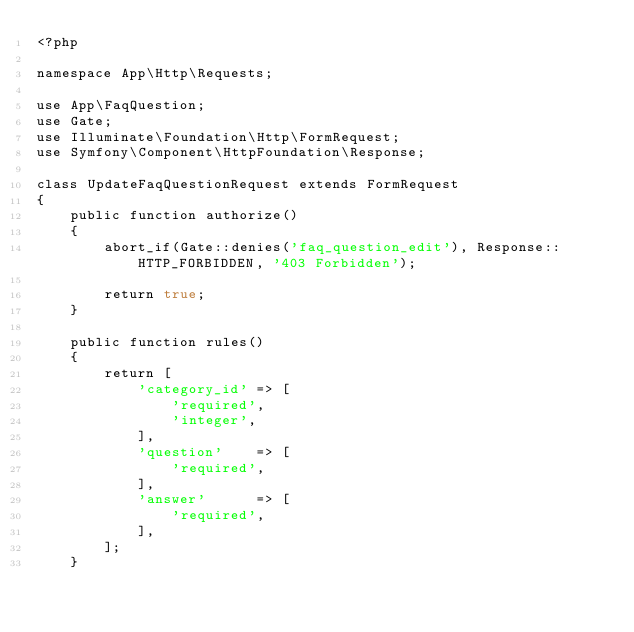Convert code to text. <code><loc_0><loc_0><loc_500><loc_500><_PHP_><?php

namespace App\Http\Requests;

use App\FaqQuestion;
use Gate;
use Illuminate\Foundation\Http\FormRequest;
use Symfony\Component\HttpFoundation\Response;

class UpdateFaqQuestionRequest extends FormRequest
{
    public function authorize()
    {
        abort_if(Gate::denies('faq_question_edit'), Response::HTTP_FORBIDDEN, '403 Forbidden');

        return true;
    }

    public function rules()
    {
        return [
            'category_id' => [
                'required',
                'integer',
            ],
            'question'    => [
                'required',
            ],
            'answer'      => [
                'required',
            ],
        ];
    }</code> 